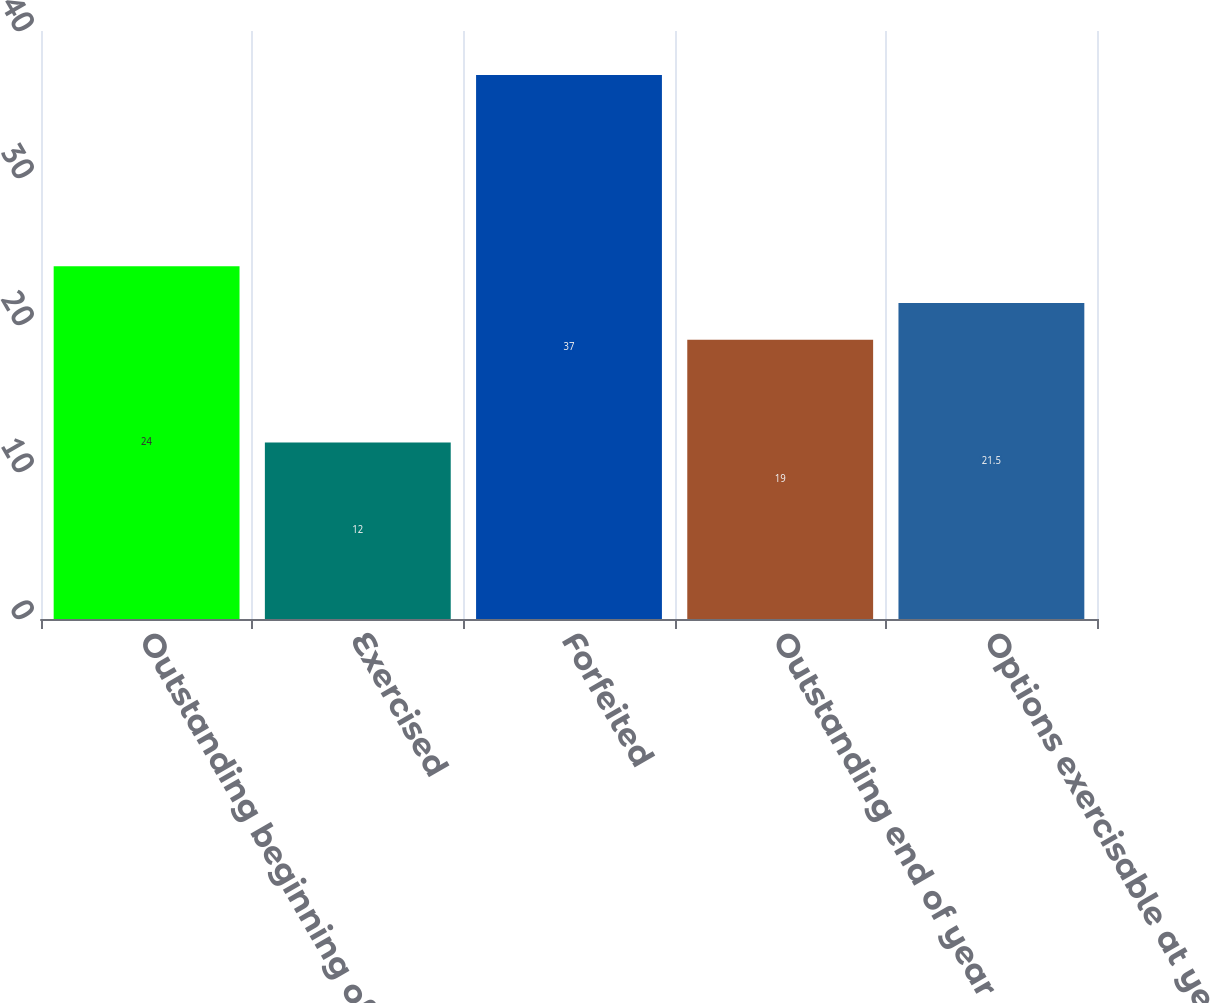<chart> <loc_0><loc_0><loc_500><loc_500><bar_chart><fcel>Outstanding beginning of year<fcel>Exercised<fcel>Forfeited<fcel>Outstanding end of year<fcel>Options exercisable at year<nl><fcel>24<fcel>12<fcel>37<fcel>19<fcel>21.5<nl></chart> 